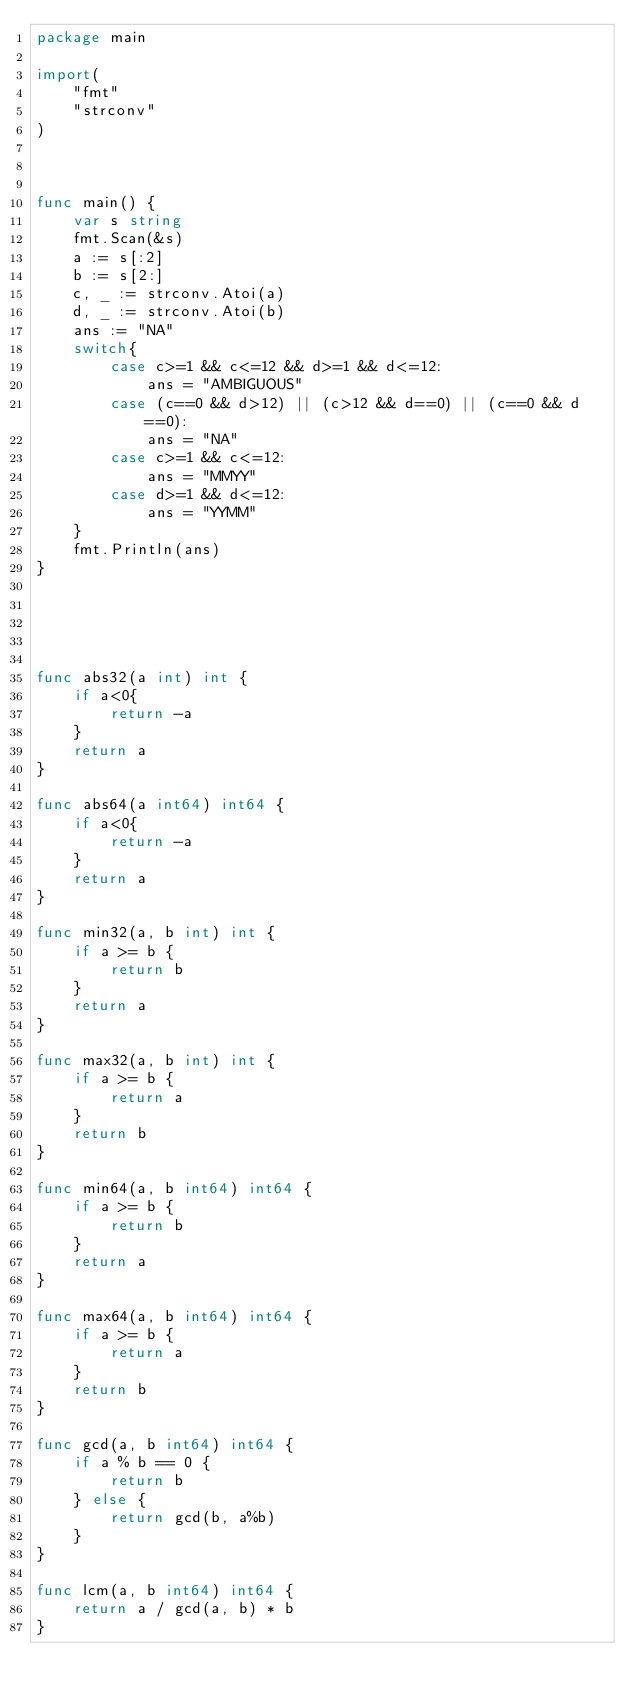<code> <loc_0><loc_0><loc_500><loc_500><_Go_>package main

import(
    "fmt"
    "strconv"
)



func main() {
    var s string
    fmt.Scan(&s)
    a := s[:2]
    b := s[2:]
    c, _ := strconv.Atoi(a)
    d, _ := strconv.Atoi(b)
    ans := "NA"
    switch{
        case c>=1 && c<=12 && d>=1 && d<=12:
            ans = "AMBIGUOUS"
        case (c==0 && d>12) || (c>12 && d==0) || (c==0 && d==0):
            ans = "NA"
        case c>=1 && c<=12:
            ans = "MMYY"
        case d>=1 && d<=12:
            ans = "YYMM"
    }
    fmt.Println(ans)
}





func abs32(a int) int {
    if a<0{
        return -a
    }
    return a
}

func abs64(a int64) int64 {
    if a<0{
        return -a
    }
    return a
}

func min32(a, b int) int {
    if a >= b {
        return b
    }
    return a
}

func max32(a, b int) int {
    if a >= b {
        return a
    }
    return b
}

func min64(a, b int64) int64 {
    if a >= b {
        return b
    }
    return a
}

func max64(a, b int64) int64 {
    if a >= b {
        return a
    }
    return b
}

func gcd(a, b int64) int64 {
    if a % b == 0 {
        return b
    } else {
        return gcd(b, a%b)
    }
}

func lcm(a, b int64) int64 {
    return a / gcd(a, b) * b
}
</code> 